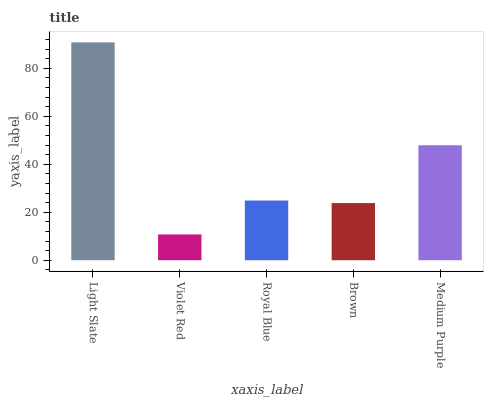Is Violet Red the minimum?
Answer yes or no. Yes. Is Light Slate the maximum?
Answer yes or no. Yes. Is Royal Blue the minimum?
Answer yes or no. No. Is Royal Blue the maximum?
Answer yes or no. No. Is Royal Blue greater than Violet Red?
Answer yes or no. Yes. Is Violet Red less than Royal Blue?
Answer yes or no. Yes. Is Violet Red greater than Royal Blue?
Answer yes or no. No. Is Royal Blue less than Violet Red?
Answer yes or no. No. Is Royal Blue the high median?
Answer yes or no. Yes. Is Royal Blue the low median?
Answer yes or no. Yes. Is Medium Purple the high median?
Answer yes or no. No. Is Light Slate the low median?
Answer yes or no. No. 